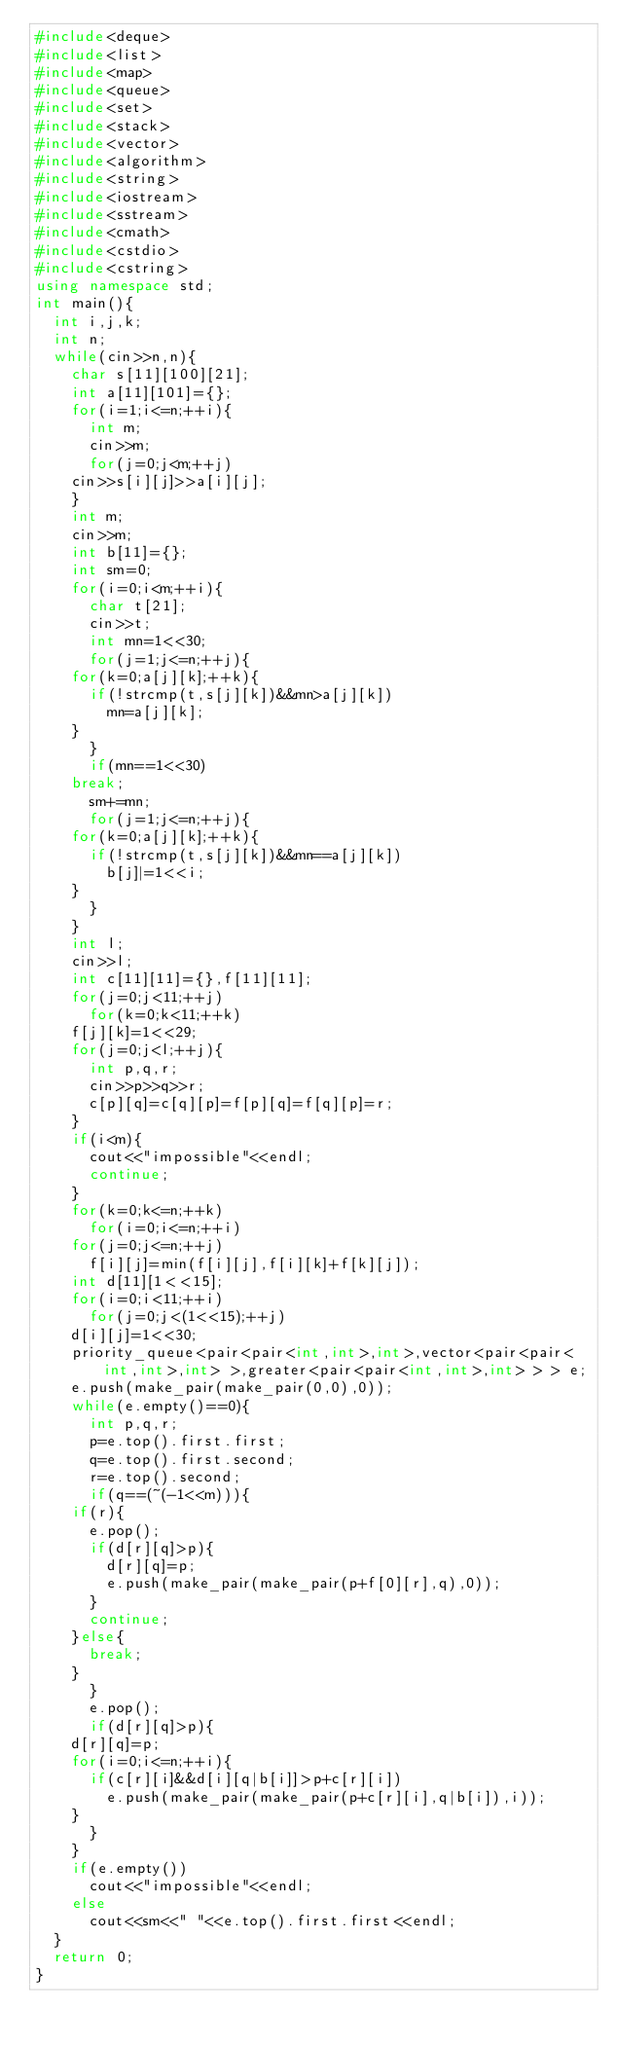Convert code to text. <code><loc_0><loc_0><loc_500><loc_500><_C++_>#include<deque>
#include<list>
#include<map>
#include<queue>
#include<set>
#include<stack>
#include<vector>
#include<algorithm>
#include<string>
#include<iostream>
#include<sstream>
#include<cmath>
#include<cstdio>
#include<cstring>
using namespace std;
int main(){
  int i,j,k;
  int n;
  while(cin>>n,n){
    char s[11][100][21];
    int a[11][101]={};
    for(i=1;i<=n;++i){
      int m;
      cin>>m;
      for(j=0;j<m;++j)
	cin>>s[i][j]>>a[i][j];
    }
    int m;
    cin>>m;
    int b[11]={};
    int sm=0;
    for(i=0;i<m;++i){
      char t[21];
      cin>>t;
      int mn=1<<30;
      for(j=1;j<=n;++j){
	for(k=0;a[j][k];++k){
	  if(!strcmp(t,s[j][k])&&mn>a[j][k])
	    mn=a[j][k];
	}
      }
      if(mn==1<<30)
	break;
      sm+=mn;
      for(j=1;j<=n;++j){
	for(k=0;a[j][k];++k){
	  if(!strcmp(t,s[j][k])&&mn==a[j][k])
	    b[j]|=1<<i;
	}
      }
    }
    int l;
    cin>>l;
    int c[11][11]={},f[11][11];
    for(j=0;j<11;++j)
      for(k=0;k<11;++k)
	f[j][k]=1<<29;
    for(j=0;j<l;++j){
      int p,q,r;
      cin>>p>>q>>r;
      c[p][q]=c[q][p]=f[p][q]=f[q][p]=r;
    }
    if(i<m){
      cout<<"impossible"<<endl;
      continue;
    }
    for(k=0;k<=n;++k)
      for(i=0;i<=n;++i)
	for(j=0;j<=n;++j)
	  f[i][j]=min(f[i][j],f[i][k]+f[k][j]);
    int d[11][1<<15];
    for(i=0;i<11;++i)
      for(j=0;j<(1<<15);++j)
	d[i][j]=1<<30;
    priority_queue<pair<pair<int,int>,int>,vector<pair<pair<int,int>,int> >,greater<pair<pair<int,int>,int> > > e;
    e.push(make_pair(make_pair(0,0),0));
    while(e.empty()==0){
      int p,q,r;
      p=e.top().first.first;
      q=e.top().first.second;
      r=e.top().second;
      if(q==(~(-1<<m))){
	if(r){
	  e.pop();
	  if(d[r][q]>p){
	    d[r][q]=p;
	    e.push(make_pair(make_pair(p+f[0][r],q),0));
	  }
	  continue;
	}else{
	  break;
	}
      }
      e.pop();
      if(d[r][q]>p){
	d[r][q]=p;
	for(i=0;i<=n;++i){
	  if(c[r][i]&&d[i][q|b[i]]>p+c[r][i])
	    e.push(make_pair(make_pair(p+c[r][i],q|b[i]),i));
	}
      }
    }
    if(e.empty())
      cout<<"impossible"<<endl;
    else
      cout<<sm<<" "<<e.top().first.first<<endl;
  }
  return 0;
}</code> 